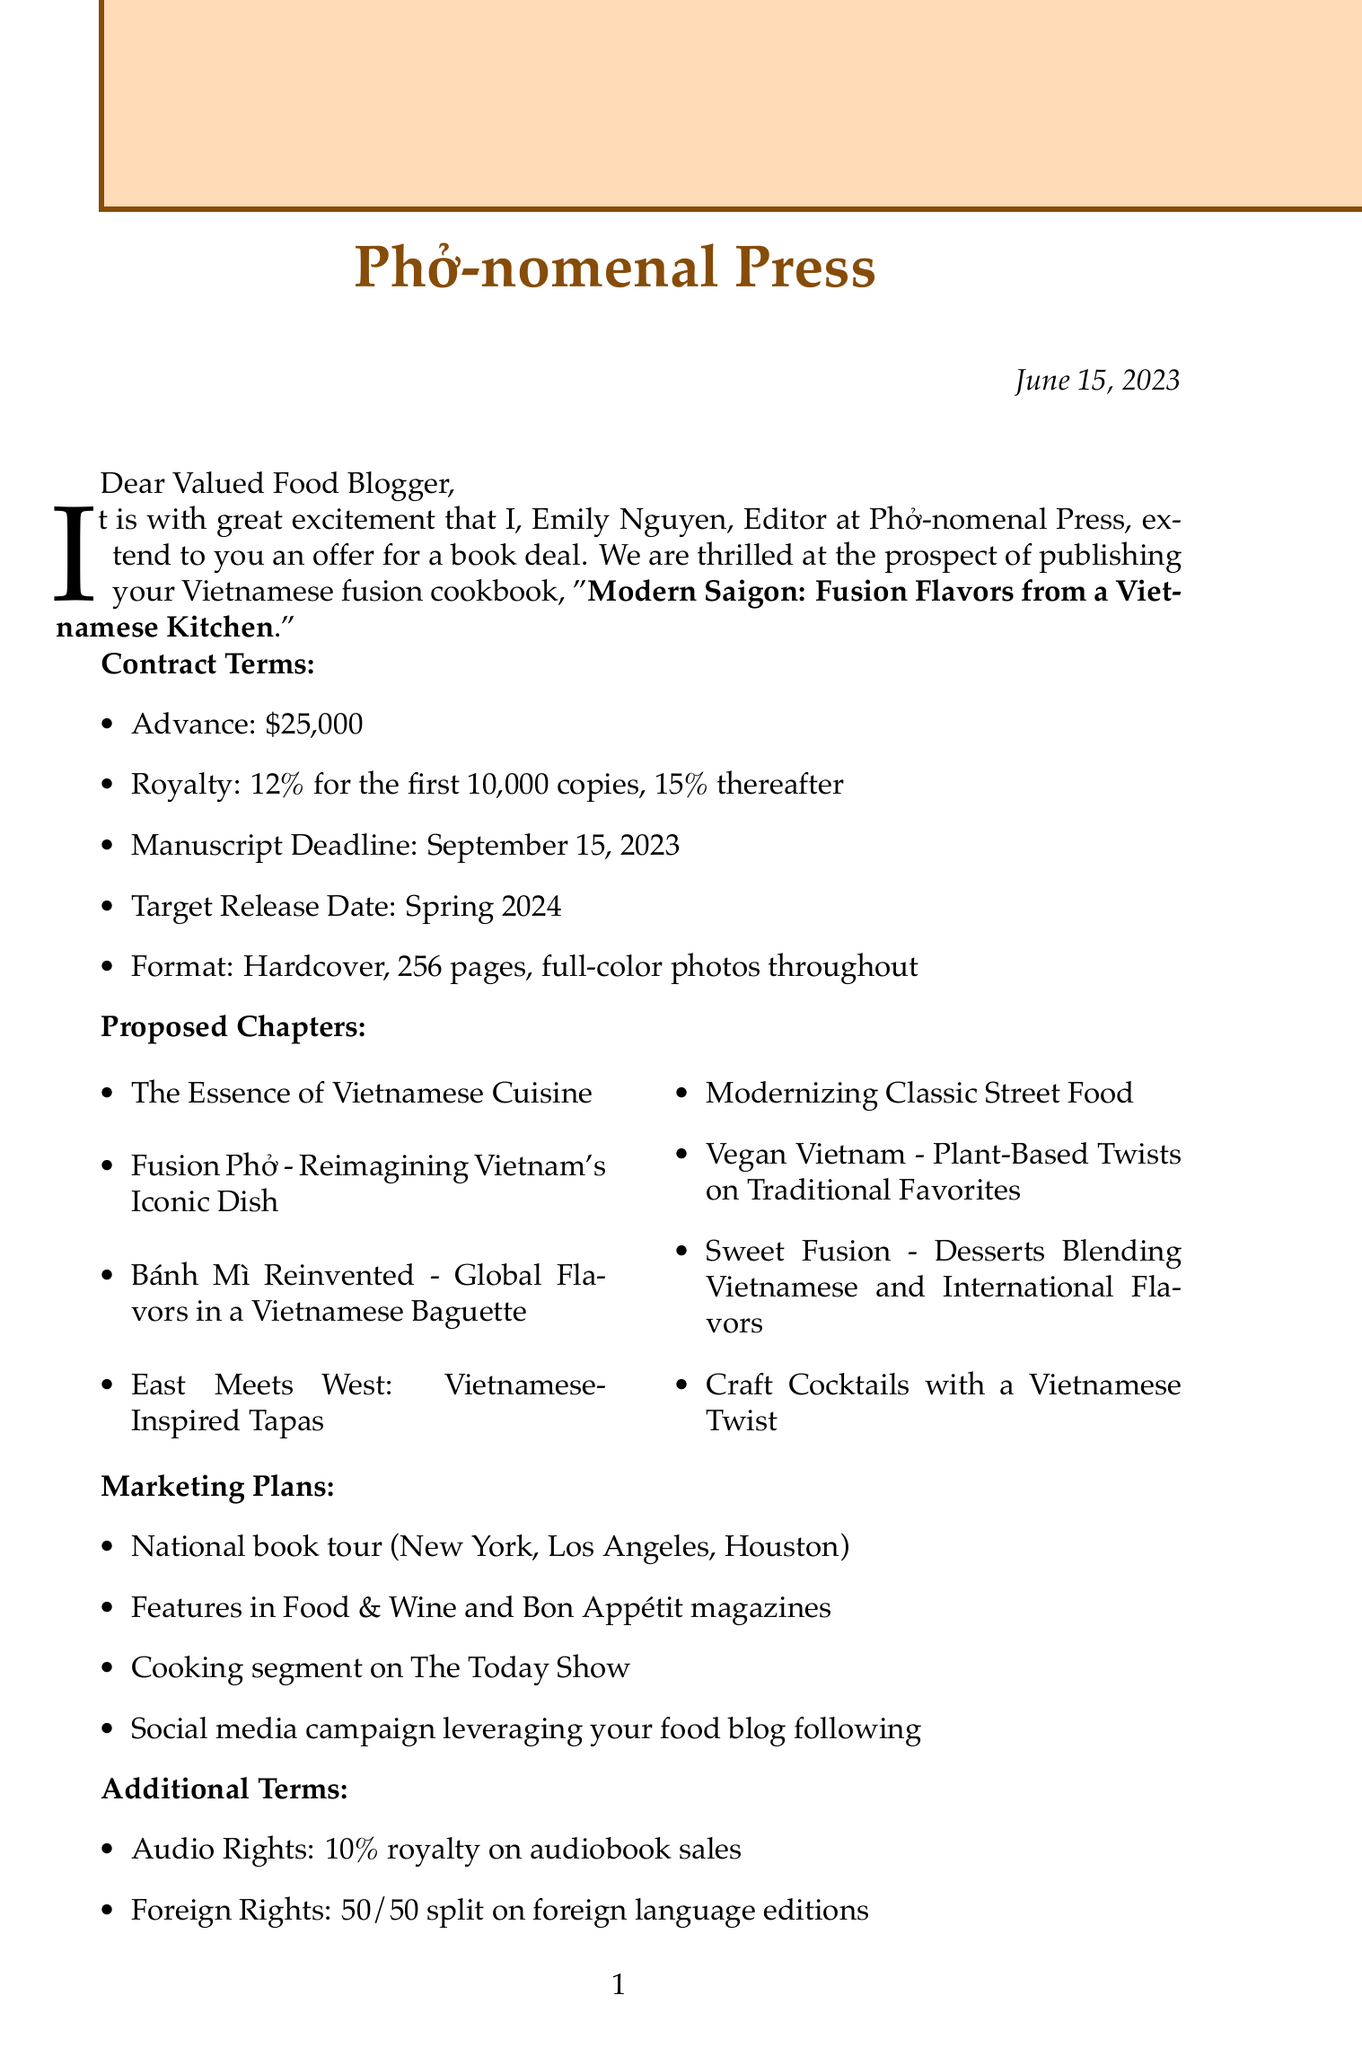What is the name of the publishing company? The publishing company mentioned in the document is Phở-nomenal Press.
Answer: Phở-nomenal Press Who is the editor of the cookbook? The editor who sent the letter is Emily Nguyen.
Answer: Emily Nguyen What is the advance amount for the book deal? The advance amount offered in the contract is $25,000.
Answer: $25,000 What is the royalty rate after the first 10,000 copies? The royalty rate increases to 15% after the first 10,000 copies.
Answer: 15% When is the manuscript deadline? The manuscript deadline specified in the document is September 15, 2023.
Answer: September 15, 2023 How many proposed chapters are listed? There are eight proposed chapters outlined in the document.
Answer: Eight What is the target release date for the cookbook? The document states the target release date is Spring 2024.
Answer: Spring 2024 What unique aspect does the editor praise about the cookbook? The editor praises the innovative approach to Vietnamese fusion cuisine as aligning with global trends.
Answer: Innovative approach to Vietnamese fusion cuisine What is included in the book format? The book format includes hardcover, 256 pages, and full-color photos throughout.
Answer: Hardcover, 256 pages, full-color photos throughout 